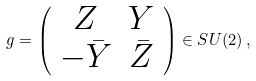<formula> <loc_0><loc_0><loc_500><loc_500>g = \left ( \begin{array} { c c } Z & Y \\ - \bar { Y } & \bar { Z } \end{array} \right ) \in S U ( 2 ) \, ,</formula> 